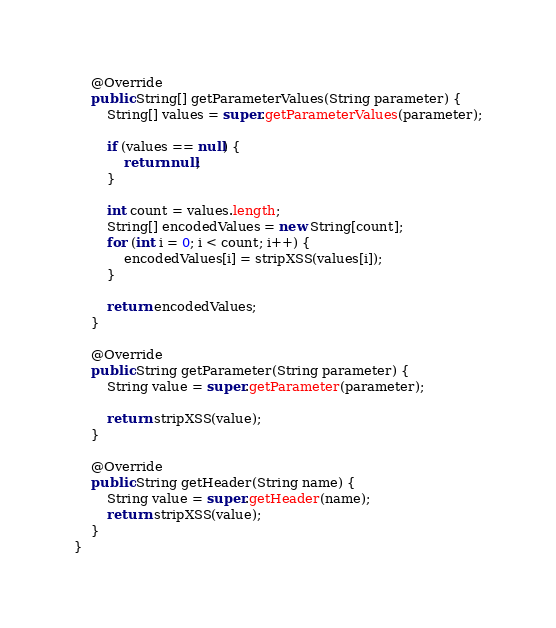<code> <loc_0><loc_0><loc_500><loc_500><_Java_>
    @Override
    public String[] getParameterValues(String parameter) {
        String[] values = super.getParameterValues(parameter);

        if (values == null) {
            return null;
        }

        int count = values.length;
        String[] encodedValues = new String[count];
        for (int i = 0; i < count; i++) {
            encodedValues[i] = stripXSS(values[i]);
        }

        return encodedValues;
    }

    @Override
    public String getParameter(String parameter) {
        String value = super.getParameter(parameter);

        return stripXSS(value);
    }

    @Override
    public String getHeader(String name) {
        String value = super.getHeader(name);
        return stripXSS(value);
    }
}</code> 